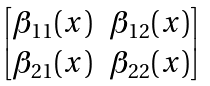Convert formula to latex. <formula><loc_0><loc_0><loc_500><loc_500>\begin{bmatrix} \beta _ { 1 1 } ( x ) & \beta _ { 1 2 } ( x ) \\ \beta _ { 2 1 } ( x ) & \beta _ { 2 2 } ( x ) \end{bmatrix}</formula> 